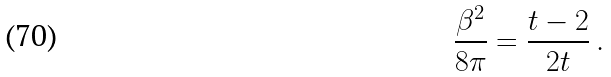Convert formula to latex. <formula><loc_0><loc_0><loc_500><loc_500>\frac { \beta ^ { 2 } } { 8 \pi } = \frac { t - 2 } { 2 t } \, .</formula> 